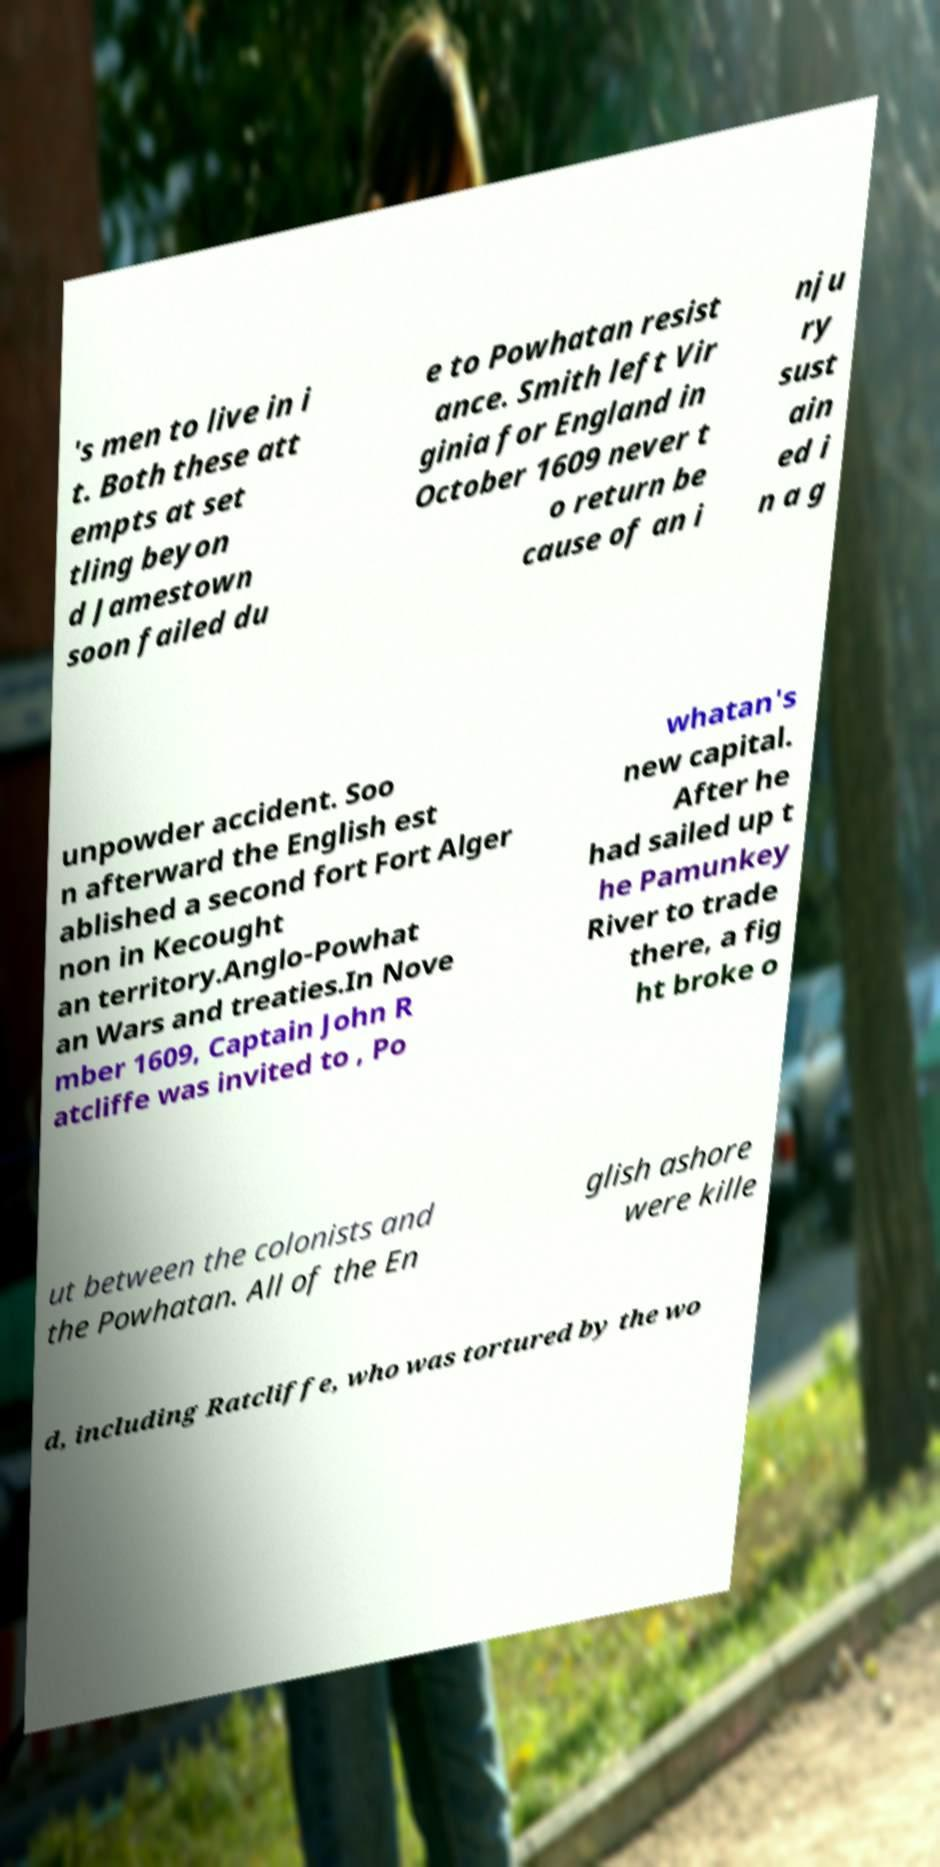There's text embedded in this image that I need extracted. Can you transcribe it verbatim? 's men to live in i t. Both these att empts at set tling beyon d Jamestown soon failed du e to Powhatan resist ance. Smith left Vir ginia for England in October 1609 never t o return be cause of an i nju ry sust ain ed i n a g unpowder accident. Soo n afterward the English est ablished a second fort Fort Alger non in Kecought an territory.Anglo-Powhat an Wars and treaties.In Nove mber 1609, Captain John R atcliffe was invited to , Po whatan's new capital. After he had sailed up t he Pamunkey River to trade there, a fig ht broke o ut between the colonists and the Powhatan. All of the En glish ashore were kille d, including Ratcliffe, who was tortured by the wo 